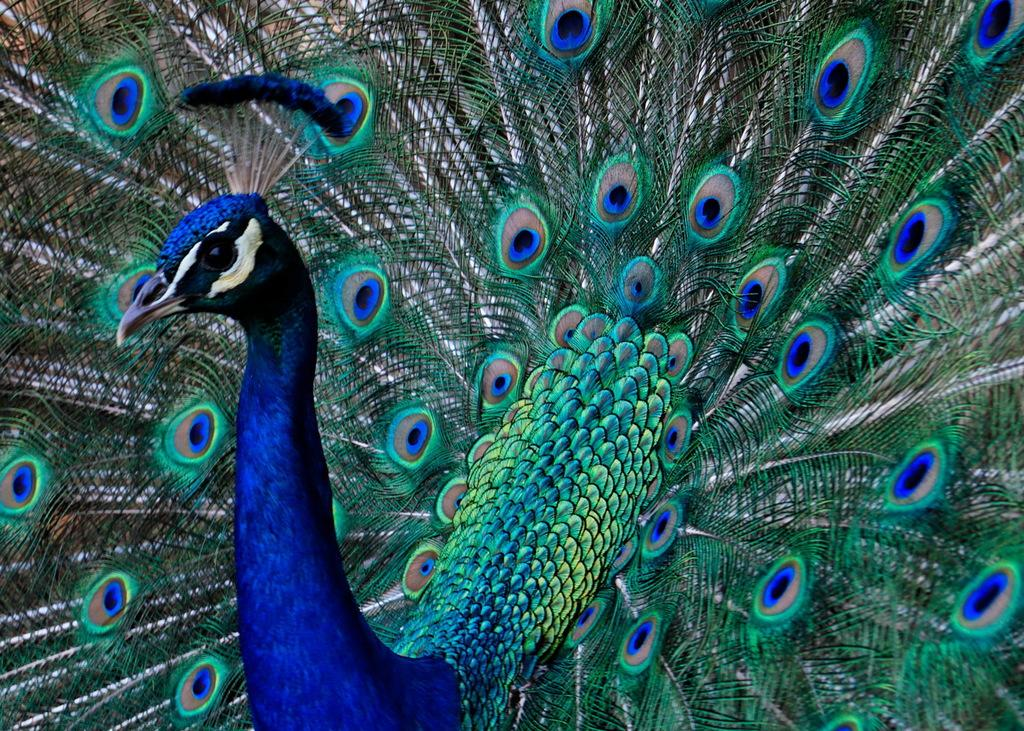What is the main subject of the image? There is a peacock in the center of the image. What type of science experiment is being conducted in the cellar in the image? There is no cellar or science experiment present in the image; it features a peacock in the center. What kind of trouble is the peacock causing in the image? There is no indication of trouble or any negative behavior in the image; the peacock is simply present in the center. 